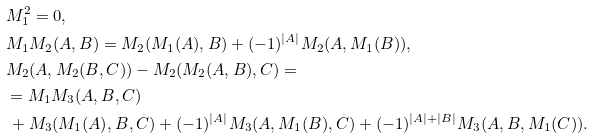Convert formula to latex. <formula><loc_0><loc_0><loc_500><loc_500>& M _ { 1 } ^ { 2 } = 0 , \\ & M _ { 1 } M _ { 2 } ( A , B ) = M _ { 2 } ( M _ { 1 } ( A ) , B ) + ( - 1 ) ^ { | A | } M _ { 2 } ( A , M _ { 1 } ( B ) ) , \\ & M _ { 2 } ( A , M _ { 2 } ( B , C ) ) - M _ { 2 } ( M _ { 2 } ( A , B ) , C ) = \\ & = M _ { 1 } M _ { 3 } ( A , B , C ) \\ & \, + M _ { 3 } ( M _ { 1 } ( A ) , B , C ) + ( - 1 ) ^ { | A | } M _ { 3 } ( A , M _ { 1 } ( B ) , C ) + ( - 1 ) ^ { | A | + | B | } M _ { 3 } ( A , B , M _ { 1 } ( C ) ) .</formula> 